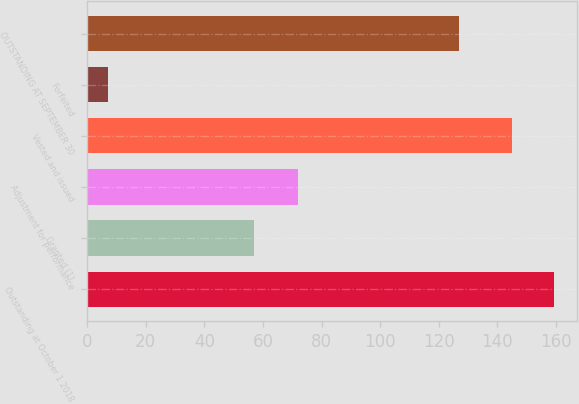Convert chart to OTSL. <chart><loc_0><loc_0><loc_500><loc_500><bar_chart><fcel>Outstanding at October 1 2018<fcel>Granted (1)<fcel>Adjustment for performance<fcel>Vested and issued<fcel>Forfeited<fcel>OUTSTANDING AT SEPTEMBER 30<nl><fcel>159.3<fcel>57<fcel>72<fcel>145<fcel>7<fcel>127<nl></chart> 